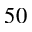<formula> <loc_0><loc_0><loc_500><loc_500>5 0</formula> 